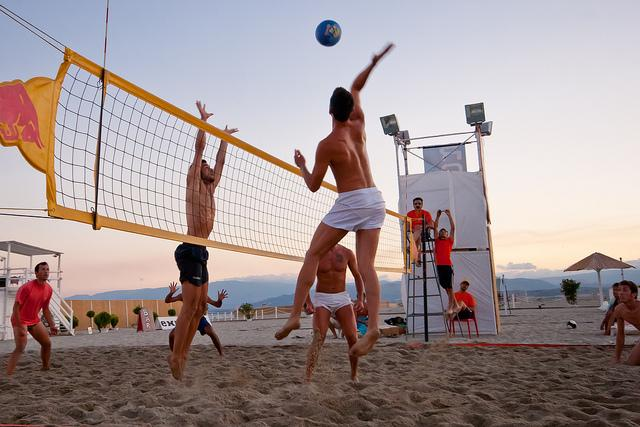What type volleyball is being played here?

Choices:
A) lawn
B) tennis
C) beach
D) professional surface beach 